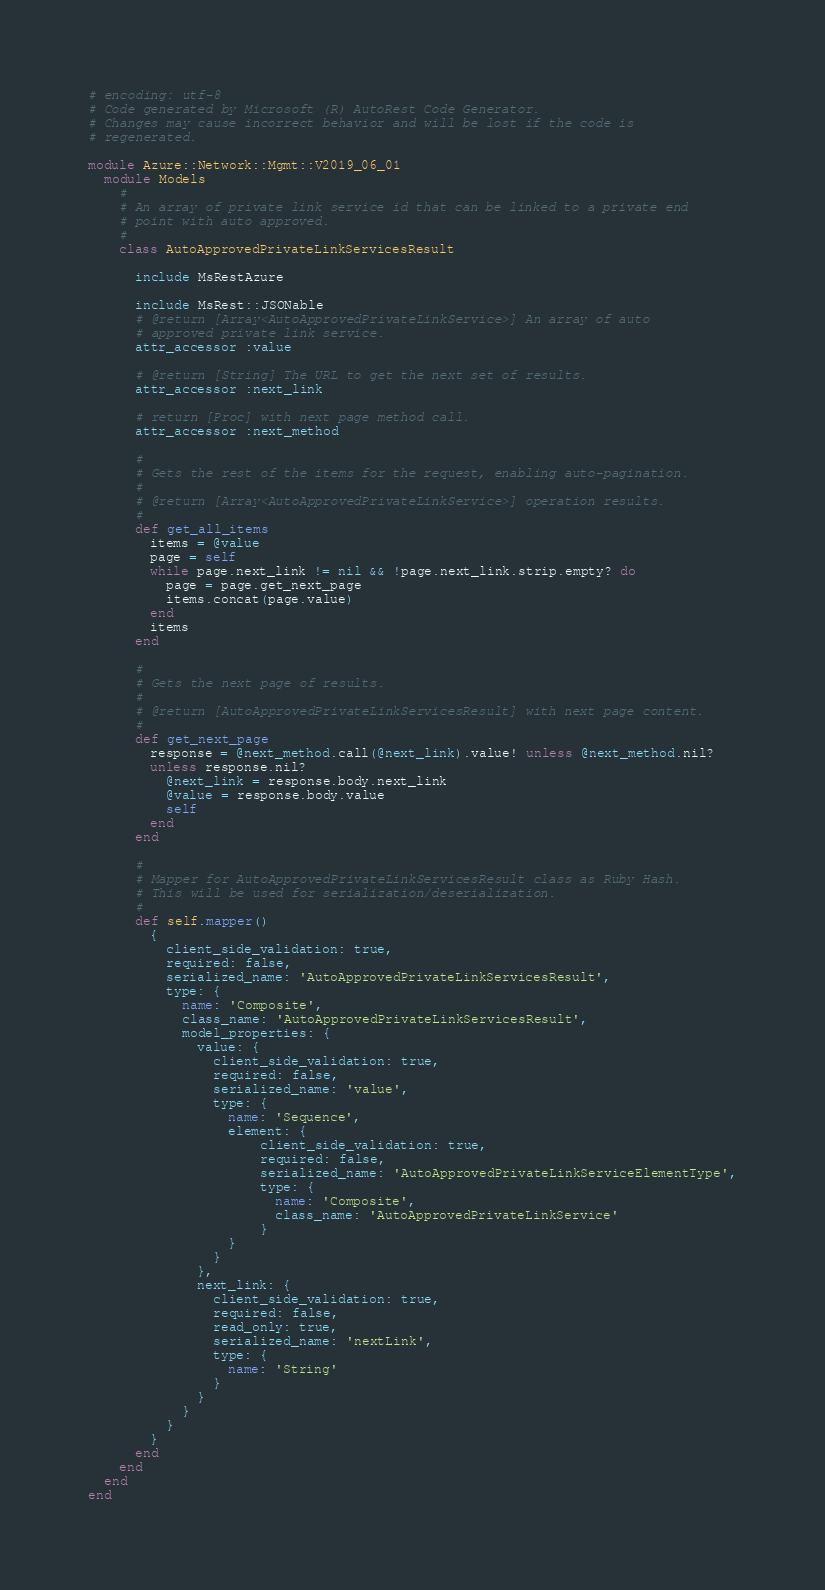<code> <loc_0><loc_0><loc_500><loc_500><_Ruby_># encoding: utf-8
# Code generated by Microsoft (R) AutoRest Code Generator.
# Changes may cause incorrect behavior and will be lost if the code is
# regenerated.

module Azure::Network::Mgmt::V2019_06_01
  module Models
    #
    # An array of private link service id that can be linked to a private end
    # point with auto approved.
    #
    class AutoApprovedPrivateLinkServicesResult

      include MsRestAzure

      include MsRest::JSONable
      # @return [Array<AutoApprovedPrivateLinkService>] An array of auto
      # approved private link service.
      attr_accessor :value

      # @return [String] The URL to get the next set of results.
      attr_accessor :next_link

      # return [Proc] with next page method call.
      attr_accessor :next_method

      #
      # Gets the rest of the items for the request, enabling auto-pagination.
      #
      # @return [Array<AutoApprovedPrivateLinkService>] operation results.
      #
      def get_all_items
        items = @value
        page = self
        while page.next_link != nil && !page.next_link.strip.empty? do
          page = page.get_next_page
          items.concat(page.value)
        end
        items
      end

      #
      # Gets the next page of results.
      #
      # @return [AutoApprovedPrivateLinkServicesResult] with next page content.
      #
      def get_next_page
        response = @next_method.call(@next_link).value! unless @next_method.nil?
        unless response.nil?
          @next_link = response.body.next_link
          @value = response.body.value
          self
        end
      end

      #
      # Mapper for AutoApprovedPrivateLinkServicesResult class as Ruby Hash.
      # This will be used for serialization/deserialization.
      #
      def self.mapper()
        {
          client_side_validation: true,
          required: false,
          serialized_name: 'AutoApprovedPrivateLinkServicesResult',
          type: {
            name: 'Composite',
            class_name: 'AutoApprovedPrivateLinkServicesResult',
            model_properties: {
              value: {
                client_side_validation: true,
                required: false,
                serialized_name: 'value',
                type: {
                  name: 'Sequence',
                  element: {
                      client_side_validation: true,
                      required: false,
                      serialized_name: 'AutoApprovedPrivateLinkServiceElementType',
                      type: {
                        name: 'Composite',
                        class_name: 'AutoApprovedPrivateLinkService'
                      }
                  }
                }
              },
              next_link: {
                client_side_validation: true,
                required: false,
                read_only: true,
                serialized_name: 'nextLink',
                type: {
                  name: 'String'
                }
              }
            }
          }
        }
      end
    end
  end
end
</code> 